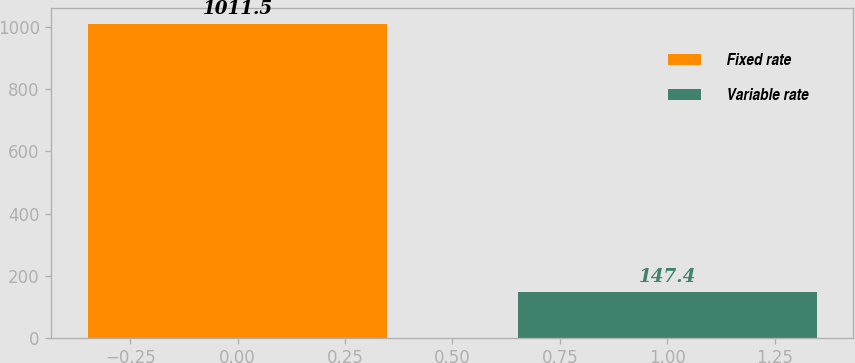<chart> <loc_0><loc_0><loc_500><loc_500><bar_chart><fcel>Fixed rate<fcel>Variable rate<nl><fcel>1011.5<fcel>147.4<nl></chart> 